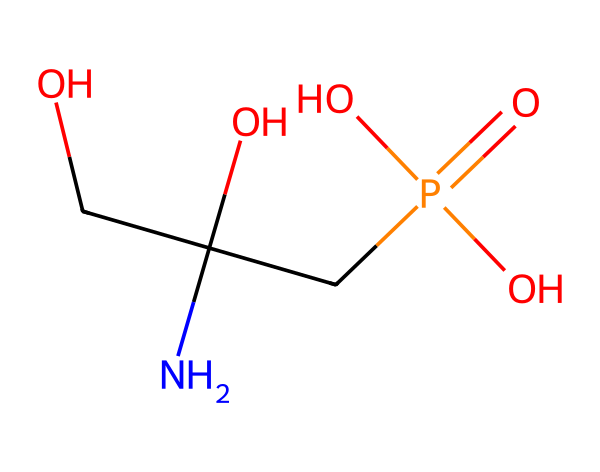What is the molecular formula of glyphosate? To find the molecular formula, count the number of each type of atom in the SMILES representation. The given structure contains 3 carbon atoms, 6 hydrogen atoms, 1 nitrogen atom, 4 oxygen atoms, and 1 phosphorus atom. Thus, the molecular formula is C3H8N1O5P1.
Answer: C3H8N1O5P1 How many oxygen atoms are present in glyphosate? By analyzing the SMILES representation, we can identify the oxygen atoms present. There are a total of 4 oxygen atoms represented in the structure.
Answer: 4 What type of functional group is identified in glyphosate? The presence of the -PO4 (phosphate) group indicates that glyphosate contains a phosphate functional group, a characteristic of many herbicides, including glyphosate.
Answer: phosphate What is the role of the nitrogen atom in glyphosate? The nitrogen atom in glyphosate is part of an amino group (NH2), which plays a crucial role in the herbicide's action by interacting with plant enzymes, influencing the herbicide's effectiveness in controlling weed growth.
Answer: amino group Does glyphosate contain any halogens in its structure? Upon examining the SMILES representation, it does not include any atoms from the halogen group (fluorine, chlorine, bromine, iodine, or astatine).
Answer: no How many phosphorous atoms are present in glyphosate? The SMILES structure shows only 1 phosphorus atom within the molecular formula, as seen in the phosphate functional group.
Answer: 1 